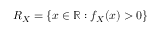<formula> <loc_0><loc_0><loc_500><loc_500>R _ { X } = \{ x \in \mathbb { R } \colon f _ { X } ( x ) > 0 \}</formula> 